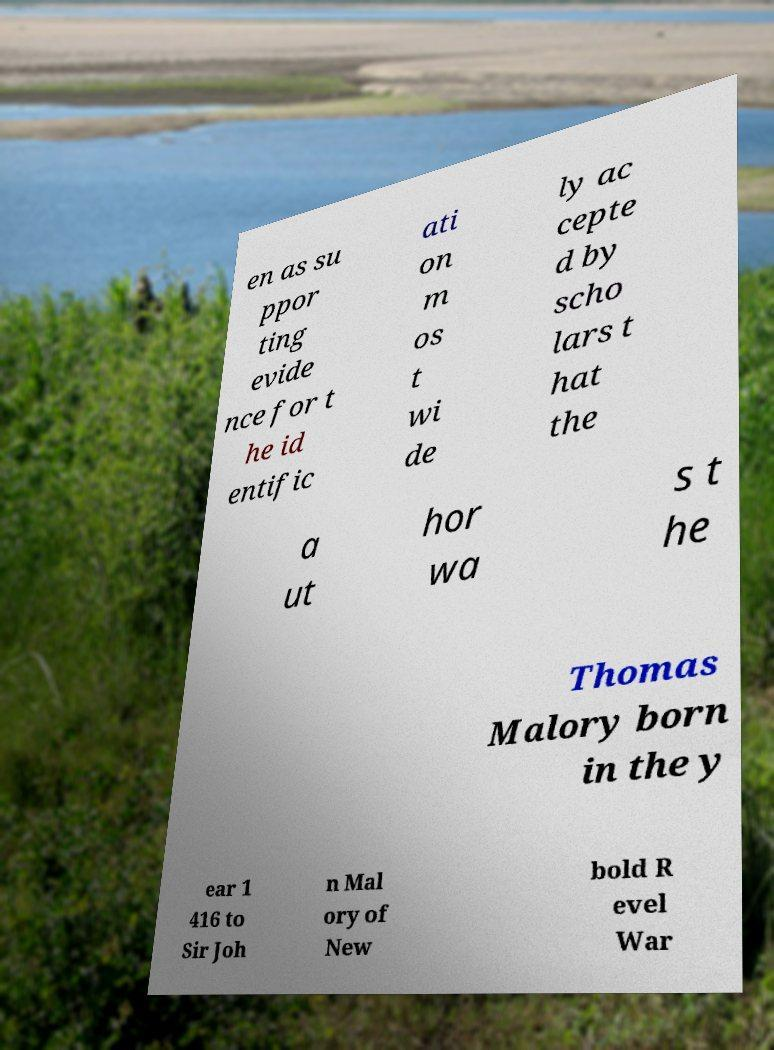Can you read and provide the text displayed in the image?This photo seems to have some interesting text. Can you extract and type it out for me? en as su ppor ting evide nce for t he id entific ati on m os t wi de ly ac cepte d by scho lars t hat the a ut hor wa s t he Thomas Malory born in the y ear 1 416 to Sir Joh n Mal ory of New bold R evel War 